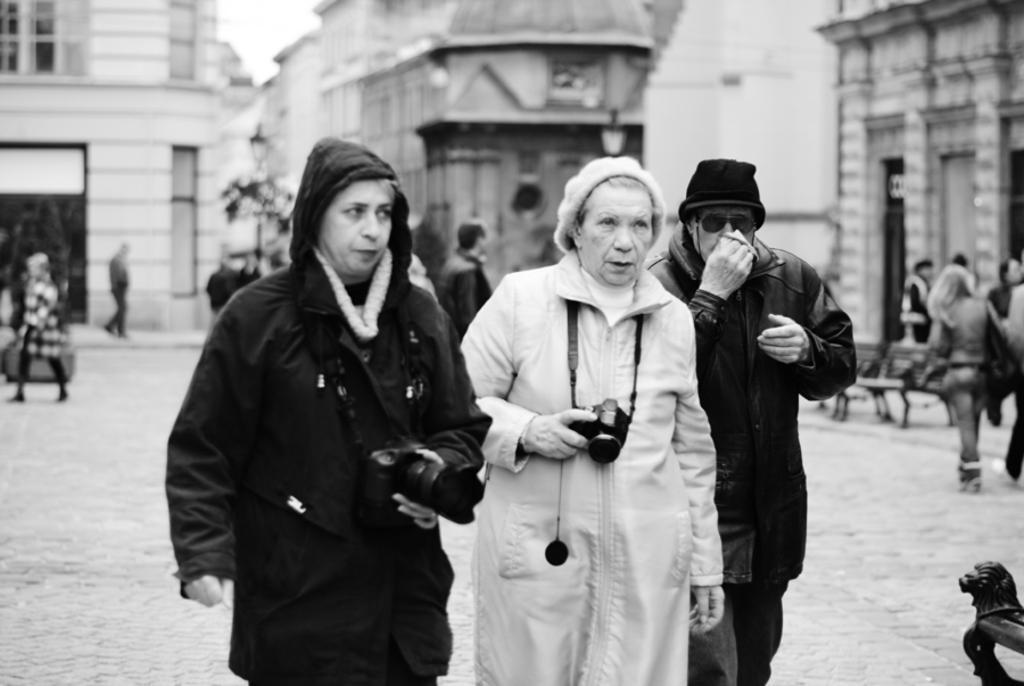Please provide a concise description of this image. This is a black and white picture and this is clicked in the street, there are many people walking on the road, in the front two women and men walking with cameras in their hands and in the back there are buildings all over the place. 